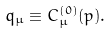Convert formula to latex. <formula><loc_0><loc_0><loc_500><loc_500>q _ { \mu } \equiv C _ { \mu } ^ { ( 0 ) } ( p ) .</formula> 